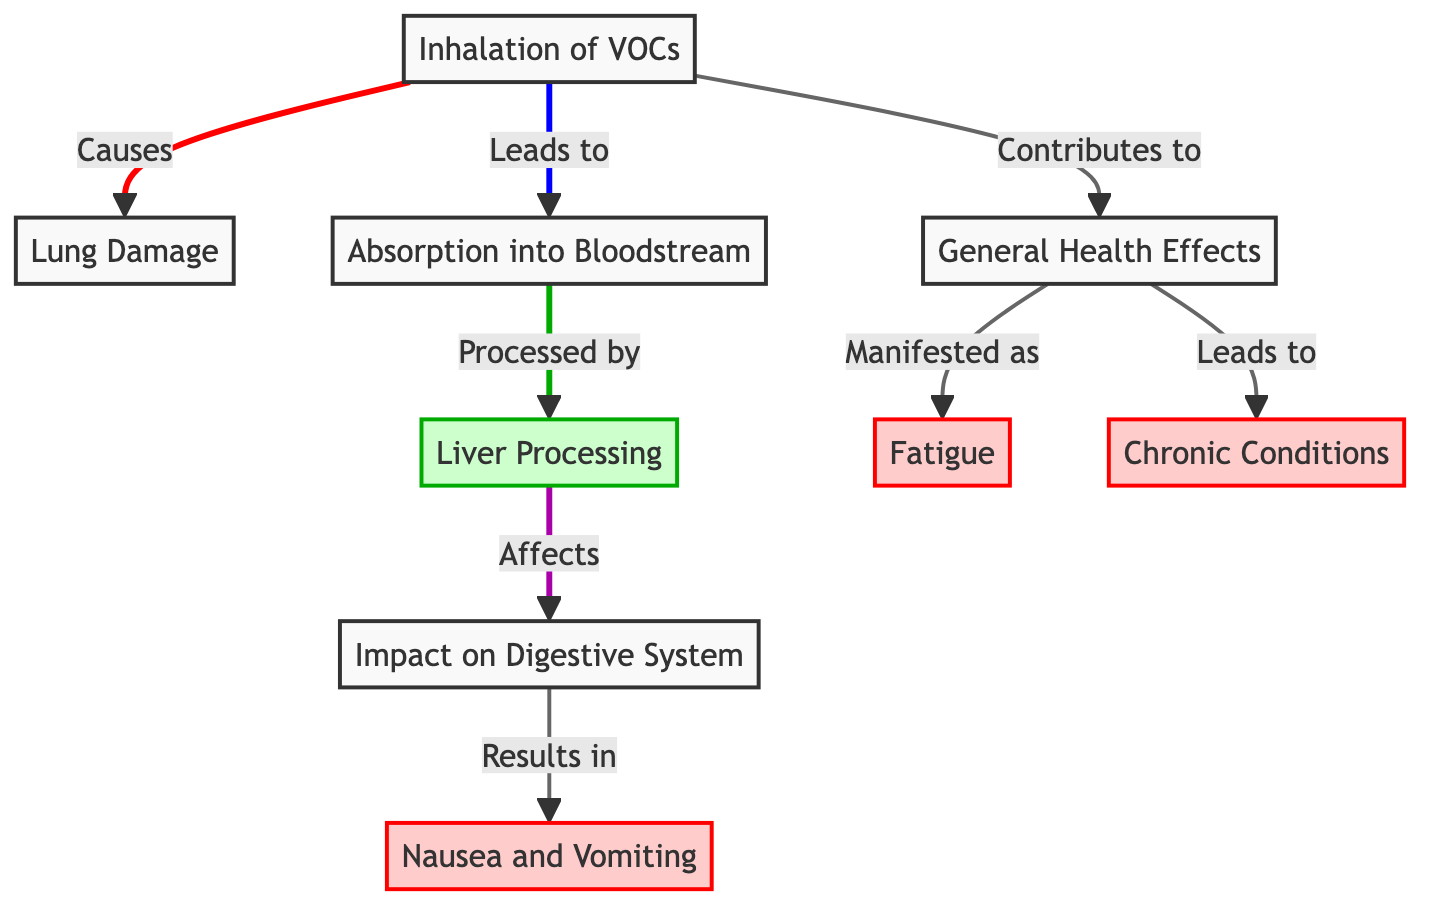What initiates the process depicted in the diagram? The diagram begins with the "Inhalation of VOCs" node, which is the first step causing subsequent effects on the body.
Answer: Inhalation of VOCs What is the first impact on the body after inhalation of VOCs? The first direct effect after inhalation is "Lung Damage," which follows immediately from the inhalation process.
Answer: Lung Damage How does liver processing relate to the digestive system? The liver processing node directly affects the "Impact on Digestive System" node, indicating that what the liver processes has repercussions for digestion.
Answer: Affects What symptoms result from the impact on the digestive system? The first symptom displayed is "Nausea and Vomiting," which stems from the effects on the digestive system as depicted in the diagram.
Answer: Nausea and Vomiting What general health effect is linked to the inhalation of VOCs? The inhalation of VOCs contributes to "General Health Effects," which encompasses various health repercussions beyond immediate symptoms.
Answer: General Health Effects Which symptom is connected to general health effects according to the diagram? The diagram indicates that "Fatigue" is one of the manifestations of the general health effects resulting from inhaled VOCs.
Answer: Fatigue How does fatigue relate to chronic conditions in the diagram? "Fatigue" is shown as a direct outcome of "General Health Effects," which may lead to the development of "Chronic Conditions" over time.
Answer: Leads to How many symptoms are shown in the diagram? There are three identified symptoms in the diagram: "Nausea and Vomiting," "Fatigue," and "Chronic Conditions."
Answer: Three symptoms What is the last node in the process flow? The final node in the flow is "Chronic Conditions," illustrating a long-term effect stemming from the previous interactions depicted in the diagram.
Answer: Chronic Conditions 